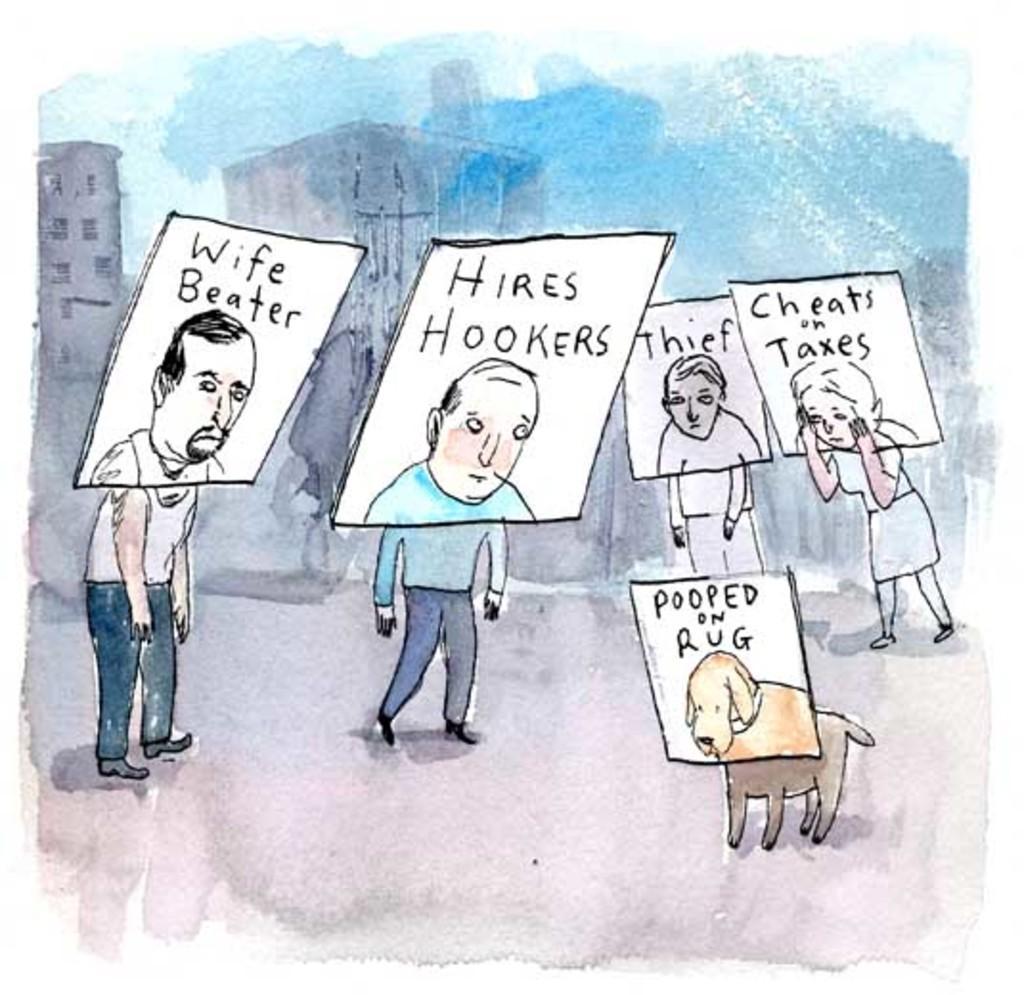Please provide a concise description of this image. This is a painting. In this image there is a painting of a group of people and holding the boards and there is a text on the boards and there is a dog. At the back there are buildings. At the top there is sky. 